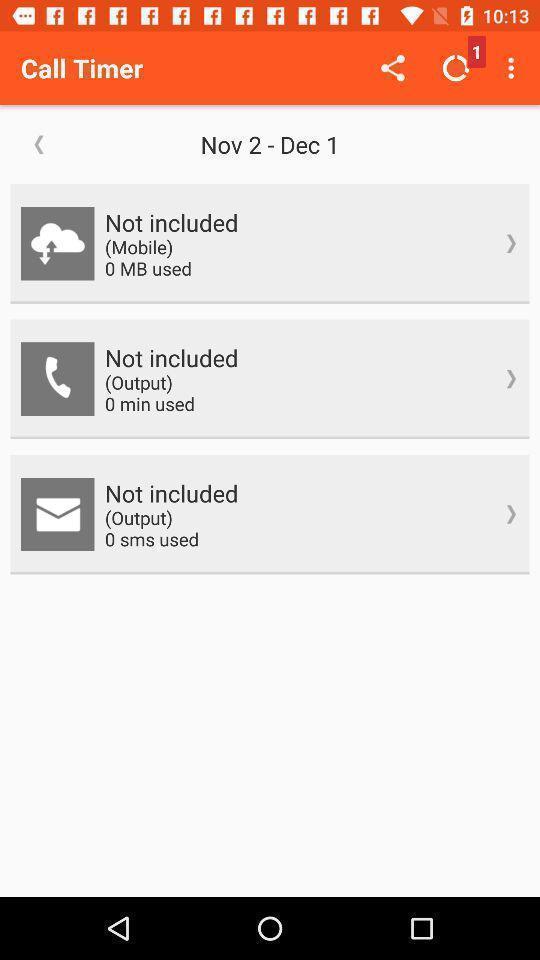Describe the key features of this screenshot. Screen shows call details in a call app. 